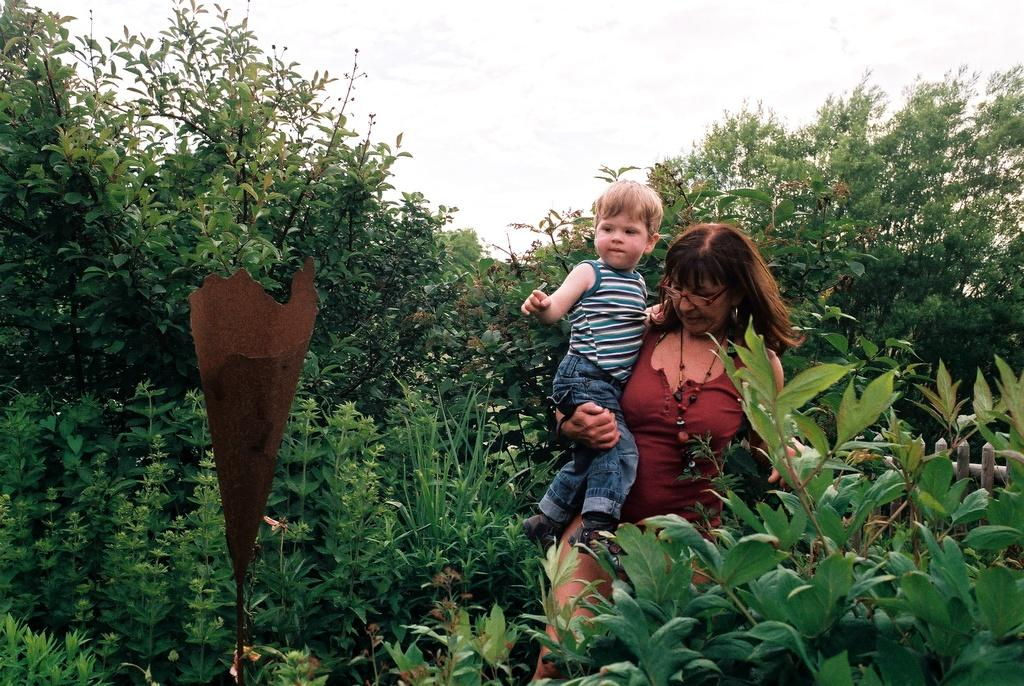How many people are present in the image? There are two persons in the image. What type of vegetation can be seen in the image? There are plants in the image, and they are green in color. What can be seen in the background of the image? The sky is visible in the background of the image, and it is white in color. Reasoning: Let' Let's think step by step in order to produce the conversation. We start by identifying the number of people in the image, which is two. Then, we describe the plants that are present, noting their color. Finally, we mention the background of the image, which includes the sky, and describe its color. Absurd Question/Answer: What type of prose is being recited by the plants in the image? There are no plants reciting prose in the image; they are simply plants. What kind of offer is being made by the persons in the image? There is no offer being made by the persons in the image; they are just present in the scene. 